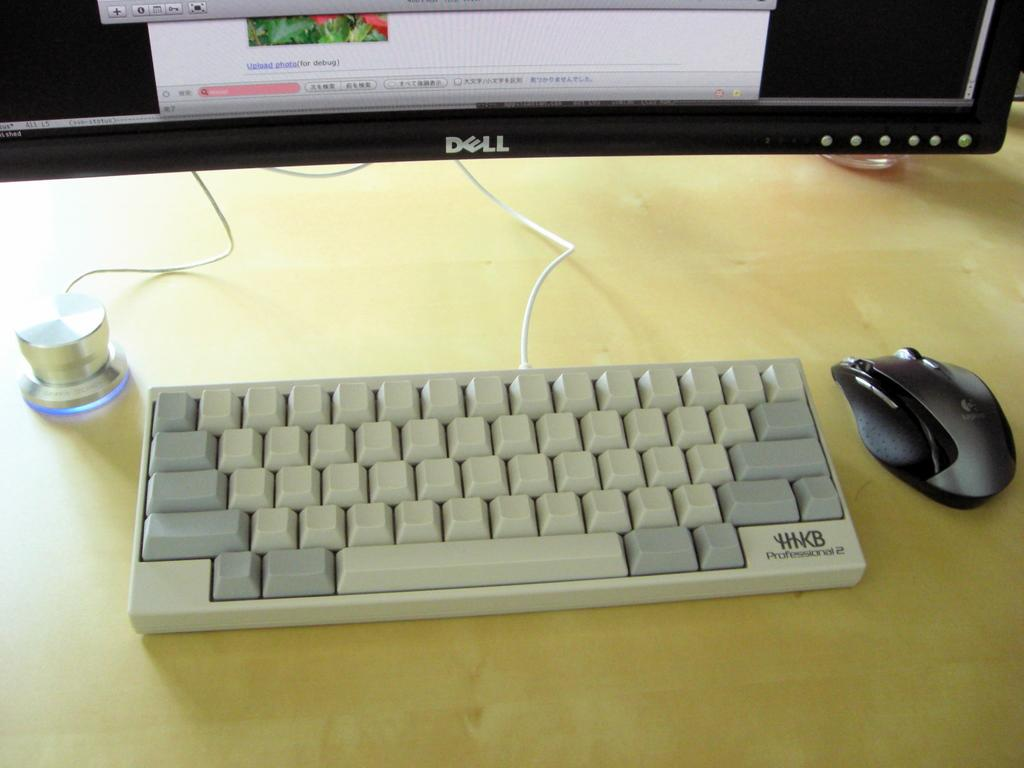What electronic device can be seen in the image? There is a monitor in the image. What input device is present in the image? There is a keyboard and a mouse in the image. Where are these objects located in the image? All these objects are present on a table. How many babies are crawling on the table in the image? There are no babies present in the image; it only features a monitor, keyboard, and mouse on a table. What type of dust can be seen on the monitor in the image? There is no dust visible on the monitor in the image. 